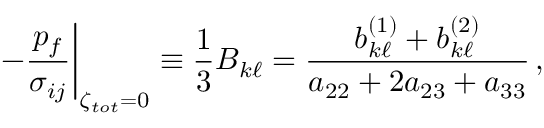Convert formula to latex. <formula><loc_0><loc_0><loc_500><loc_500>- \frac { p _ { f } } { \sigma _ { i j } } \right | _ { \zeta _ { t o t } = 0 } \equiv \frac { 1 } { 3 } B _ { k \ell } = \frac { b _ { k \ell } ^ { ( 1 ) } + b _ { k \ell } ^ { ( 2 ) } } { a _ { 2 2 } + 2 a _ { 2 3 } + a _ { 3 3 } } \, ,</formula> 